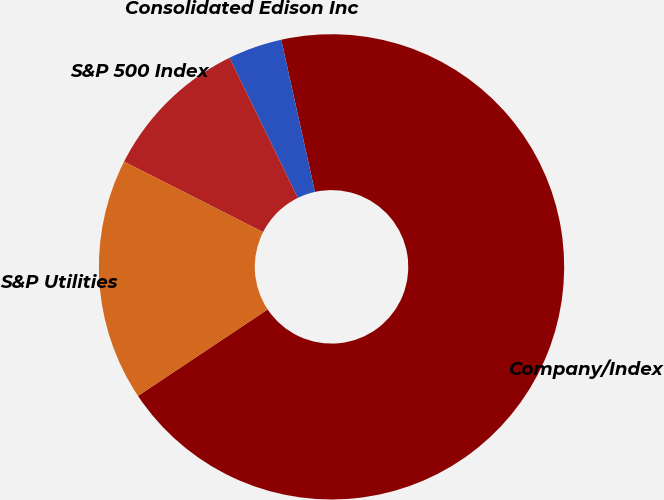<chart> <loc_0><loc_0><loc_500><loc_500><pie_chart><fcel>Company/Index<fcel>Consolidated Edison Inc<fcel>S&P 500 Index<fcel>S&P Utilities<nl><fcel>69.11%<fcel>3.76%<fcel>10.3%<fcel>16.83%<nl></chart> 